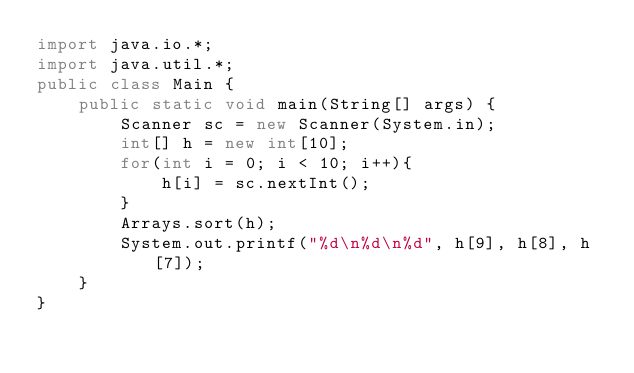Convert code to text. <code><loc_0><loc_0><loc_500><loc_500><_Java_>import java.io.*;
import java.util.*;
public class Main {
    public static void main(String[] args) {
        Scanner sc = new Scanner(System.in);
        int[] h = new int[10];
        for(int i = 0; i < 10; i++){
            h[i] = sc.nextInt();
        }
        Arrays.sort(h);
        System.out.printf("%d\n%d\n%d", h[9], h[8], h[7]);
    }
}</code> 